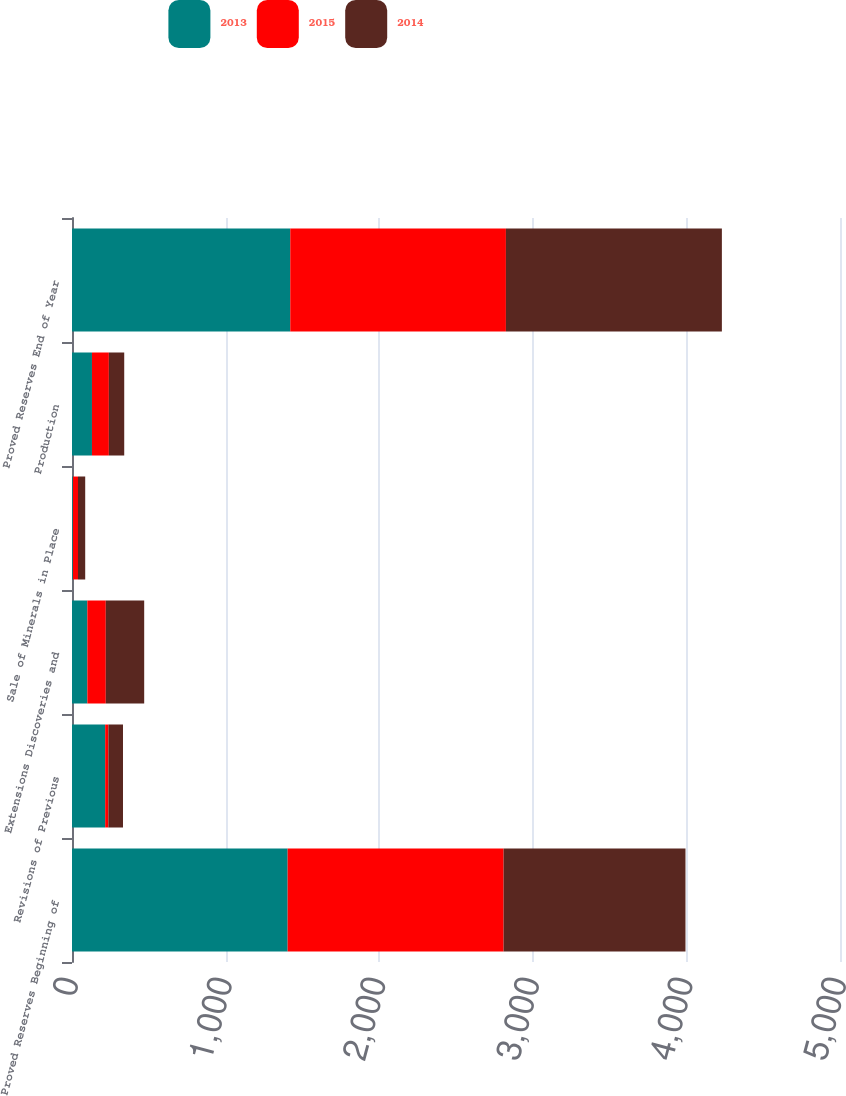<chart> <loc_0><loc_0><loc_500><loc_500><stacked_bar_chart><ecel><fcel>Proved Reserves Beginning of<fcel>Revisions of Previous<fcel>Extensions Discoveries and<fcel>Sale of Minerals in Place<fcel>Production<fcel>Proved Reserves End of Year<nl><fcel>2013<fcel>1404<fcel>216<fcel>100<fcel>6<fcel>130<fcel>1421<nl><fcel>2015<fcel>1406<fcel>21<fcel>120<fcel>33<fcel>110<fcel>1404<nl><fcel>2014<fcel>1184<fcel>95<fcel>250<fcel>47<fcel>100<fcel>1406<nl></chart> 